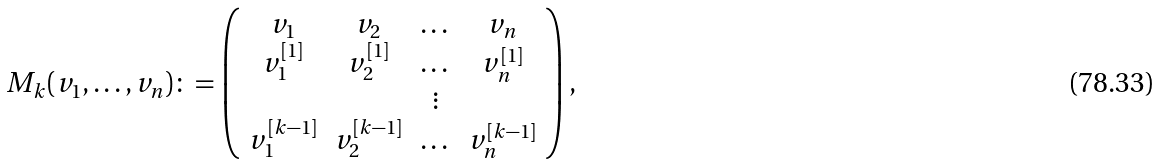Convert formula to latex. <formula><loc_0><loc_0><loc_500><loc_500>M _ { k } ( v _ { 1 } , \dots , v _ { n } ) \colon = \left ( \begin{array} { c c c c } v _ { 1 } & v _ { 2 } & \dots & v _ { n } \\ v _ { 1 } ^ { [ 1 ] } & v _ { 2 } ^ { [ 1 ] } & \dots & v _ { n } ^ { [ 1 ] } \\ & & \vdots \\ v _ { 1 } ^ { [ k - 1 ] } & v _ { 2 } ^ { [ k - 1 ] } & \dots & v _ { n } ^ { [ k - 1 ] } \end{array} \right ) ,</formula> 